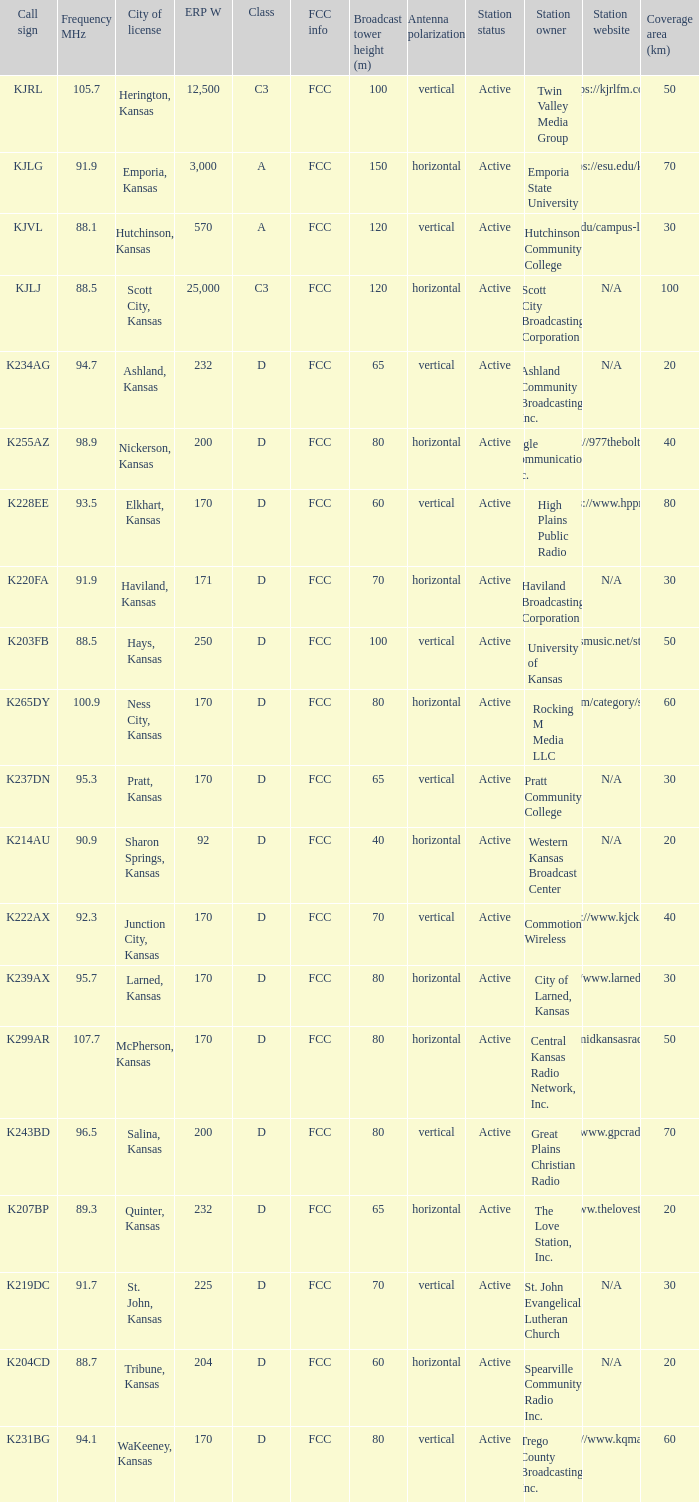Frequency MHz smaller than 95.3, and a Call sign of k234ag is what class? D. 